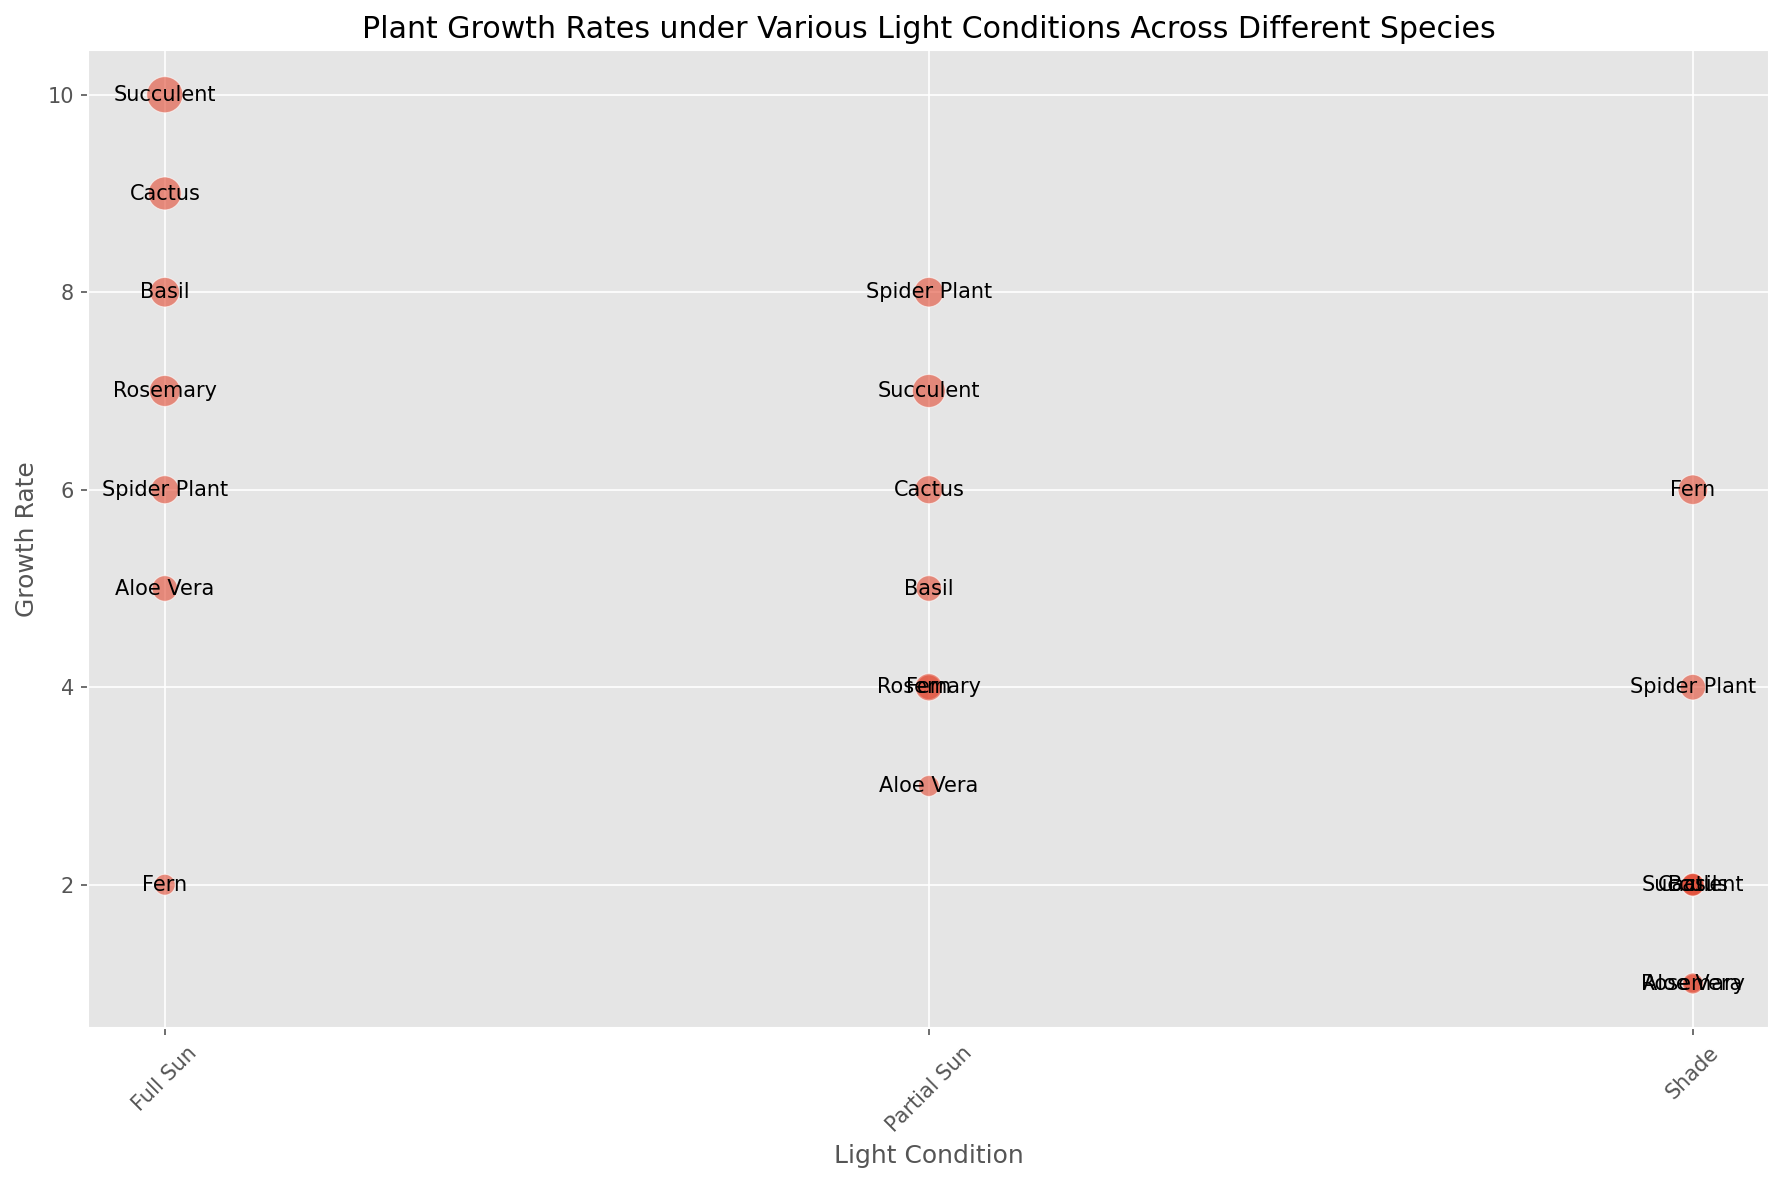What's the species with the highest growth rate under Full Sun? To find this, look at the bubbles under 'Full Sun' and identify the one with the highest position on the y-axis (Growth Rate). The highest bubble under Full Sun belongs to Succulent with a Growth Rate of 10.
Answer: Succulent Which species has the highest growth rate in the Shade? Examine the bubbles under 'Shade' and identify the one that is the highest on the y-axis (Growth Rate). The highest bubble under 'Shade' is Fern with a Growth Rate of 6.
Answer: Fern How does the growth rate of Rosemary in Full Sun compare to its growth rate in Partial Sun? Find the bubbles for Rosemary under 'Full Sun' and 'Partial Sun'. In 'Full Sun', the growth rate is 7, and in 'Partial Sun', it is 4. Comparing these, 7 is greater than 4.
Answer: Rosemary grows faster in Full Sun than in Partial Sun Which plant has the largest bubble under Partial Sun conditions? Locate the largest bubbles under 'Partial Sun'. The largest bubble is for Succulent, with a size of 25.
Answer: Succulent What's the average growth rate of Cactus under all light conditions? Locate all Cactus bubbles and calculate their growth rates' average. The growth rates are 9, 6, and 2 for Full Sun, Partial Sun, and Shade, respectively. The average is (9 + 6 + 2)/3 = 17/3 ≈ 5.67.
Answer: ≈ 5.67 What's the total size sum for Basil under all light conditions? Identify all the bubbles for Basil, then sum their sizes. The sizes are 20 (Full Sun), 15 (Partial Sun), and 10 (Shade). Total size sum = 20 + 15 + 10 = 45.
Answer: 45 Which species has a higher growth rate in the Shade compared to its growth rate in Full Sun? Compare the growth rates in Full Sun and Shade for each species. Only Fern has a higher growth rate in the Shade (6) than Full Sun (2).
Answer: Fern What is the overall trend in growth rates for Succulent across the different light conditions? Check the growth rates of Succulent under Full Sun (10), Partial Sun (7), and Shade (2). The trend is decreasing as the light condition shifts from Full Sun to Shade.
Answer: Decreasing 